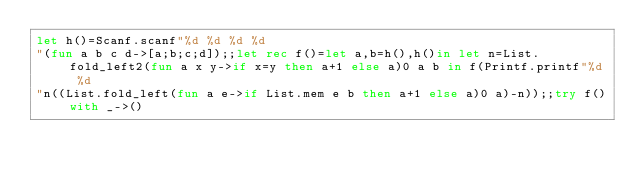Convert code to text. <code><loc_0><loc_0><loc_500><loc_500><_OCaml_>let h()=Scanf.scanf"%d %d %d %d
"(fun a b c d->[a;b;c;d]);;let rec f()=let a,b=h(),h()in let n=List.fold_left2(fun a x y->if x=y then a+1 else a)0 a b in f(Printf.printf"%d %d
"n((List.fold_left(fun a e->if List.mem e b then a+1 else a)0 a)-n));;try f()with _->()</code> 